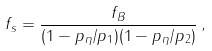Convert formula to latex. <formula><loc_0><loc_0><loc_500><loc_500>f _ { s } = \frac { f _ { B } } { ( 1 - p _ { \eta } / p _ { 1 } ) ( 1 - p _ { \eta } / p _ { 2 } ) } \, ,</formula> 